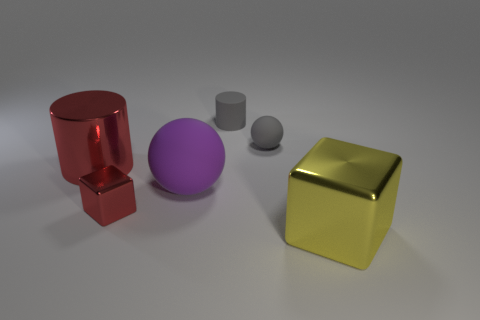Add 2 cyan rubber cylinders. How many objects exist? 8 Add 6 red cylinders. How many red cylinders are left? 7 Add 4 big metallic things. How many big metallic things exist? 6 Subtract 0 brown cylinders. How many objects are left? 6 Subtract all small purple rubber balls. Subtract all yellow shiny blocks. How many objects are left? 5 